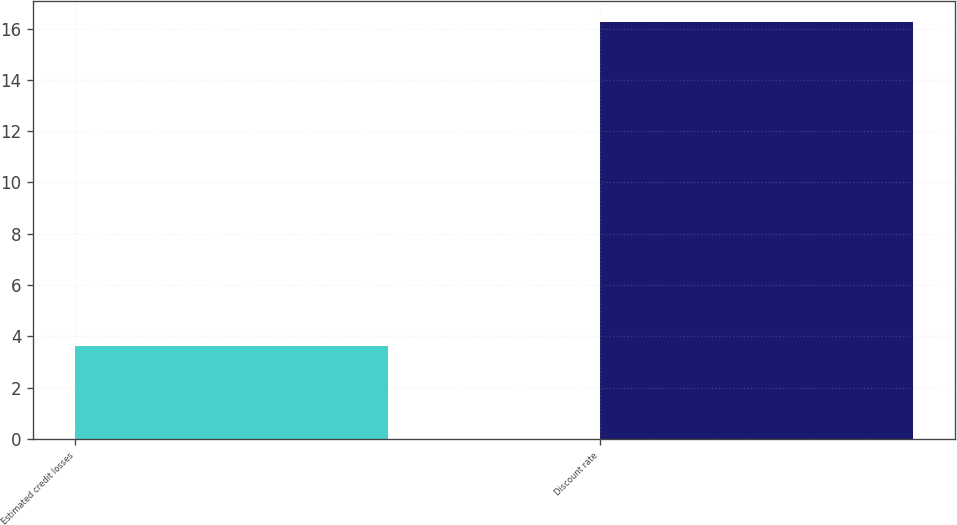<chart> <loc_0><loc_0><loc_500><loc_500><bar_chart><fcel>Estimated credit losses<fcel>Discount rate<nl><fcel>3.63<fcel>16.25<nl></chart> 